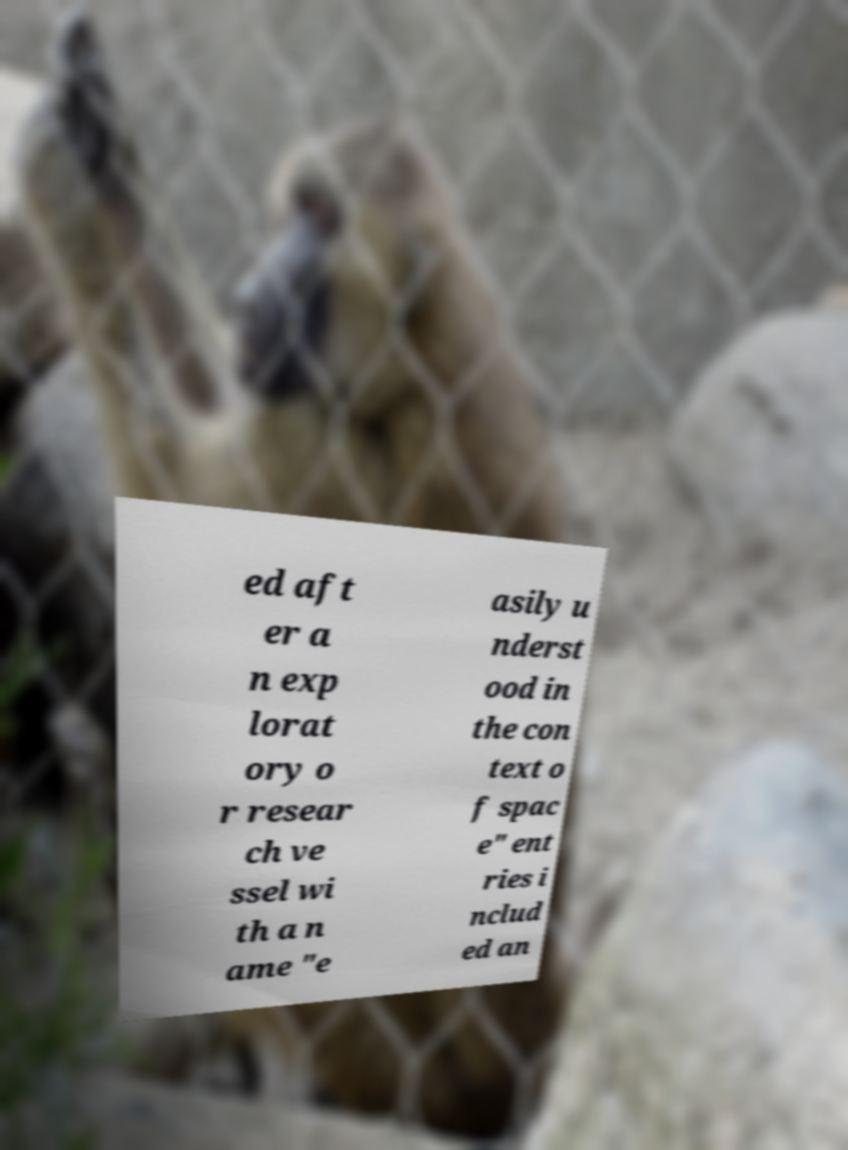What messages or text are displayed in this image? I need them in a readable, typed format. ed aft er a n exp lorat ory o r resear ch ve ssel wi th a n ame "e asily u nderst ood in the con text o f spac e" ent ries i nclud ed an 